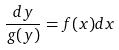<formula> <loc_0><loc_0><loc_500><loc_500>\frac { d y } { g ( y ) } = f ( x ) d x</formula> 